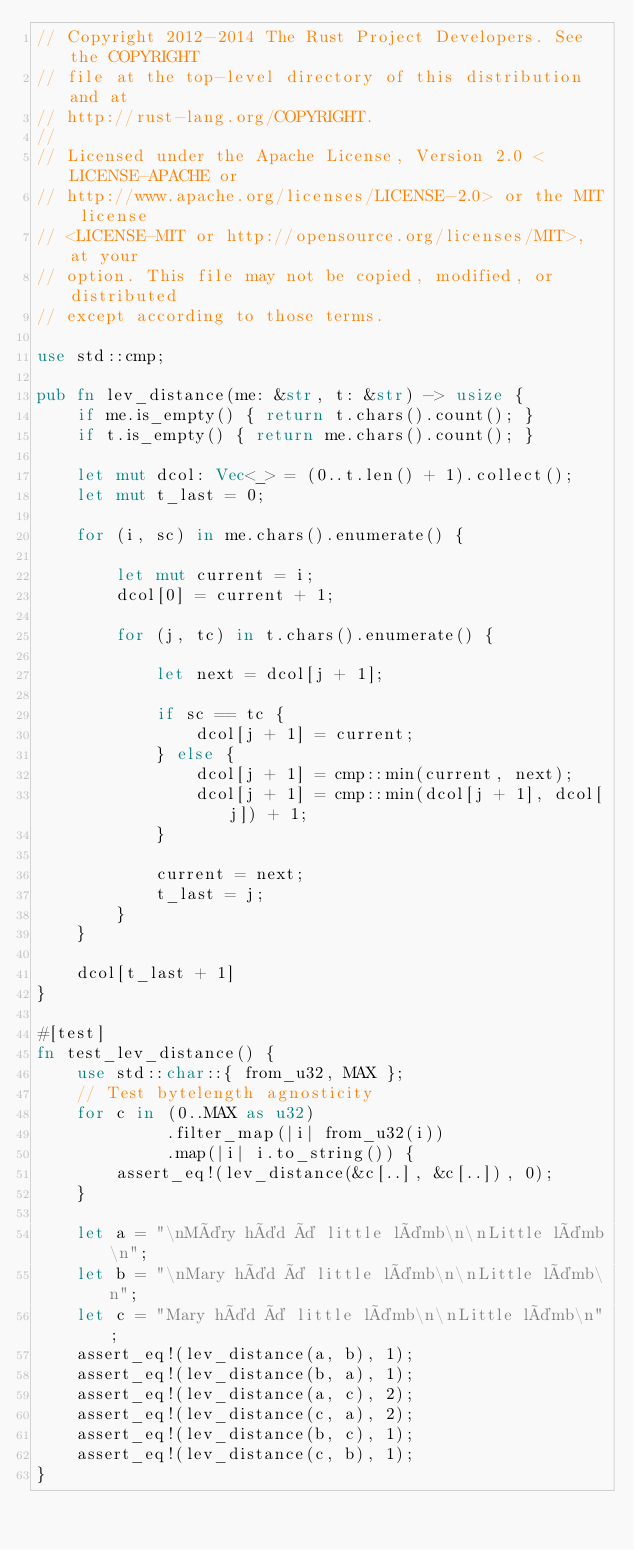<code> <loc_0><loc_0><loc_500><loc_500><_Rust_>// Copyright 2012-2014 The Rust Project Developers. See the COPYRIGHT
// file at the top-level directory of this distribution and at
// http://rust-lang.org/COPYRIGHT.
//
// Licensed under the Apache License, Version 2.0 <LICENSE-APACHE or
// http://www.apache.org/licenses/LICENSE-2.0> or the MIT license
// <LICENSE-MIT or http://opensource.org/licenses/MIT>, at your
// option. This file may not be copied, modified, or distributed
// except according to those terms.

use std::cmp;

pub fn lev_distance(me: &str, t: &str) -> usize {
    if me.is_empty() { return t.chars().count(); }
    if t.is_empty() { return me.chars().count(); }

    let mut dcol: Vec<_> = (0..t.len() + 1).collect();
    let mut t_last = 0;

    for (i, sc) in me.chars().enumerate() {

        let mut current = i;
        dcol[0] = current + 1;

        for (j, tc) in t.chars().enumerate() {

            let next = dcol[j + 1];

            if sc == tc {
                dcol[j + 1] = current;
            } else {
                dcol[j + 1] = cmp::min(current, next);
                dcol[j + 1] = cmp::min(dcol[j + 1], dcol[j]) + 1;
            }

            current = next;
            t_last = j;
        }
    }

    dcol[t_last + 1]
}

#[test]
fn test_lev_distance() {
    use std::char::{ from_u32, MAX };
    // Test bytelength agnosticity
    for c in (0..MAX as u32)
             .filter_map(|i| from_u32(i))
             .map(|i| i.to_string()) {
        assert_eq!(lev_distance(&c[..], &c[..]), 0);
    }

    let a = "\nMäry häd ä little lämb\n\nLittle lämb\n";
    let b = "\nMary häd ä little lämb\n\nLittle lämb\n";
    let c = "Mary häd ä little lämb\n\nLittle lämb\n";
    assert_eq!(lev_distance(a, b), 1);
    assert_eq!(lev_distance(b, a), 1);
    assert_eq!(lev_distance(a, c), 2);
    assert_eq!(lev_distance(c, a), 2);
    assert_eq!(lev_distance(b, c), 1);
    assert_eq!(lev_distance(c, b), 1);
}
</code> 